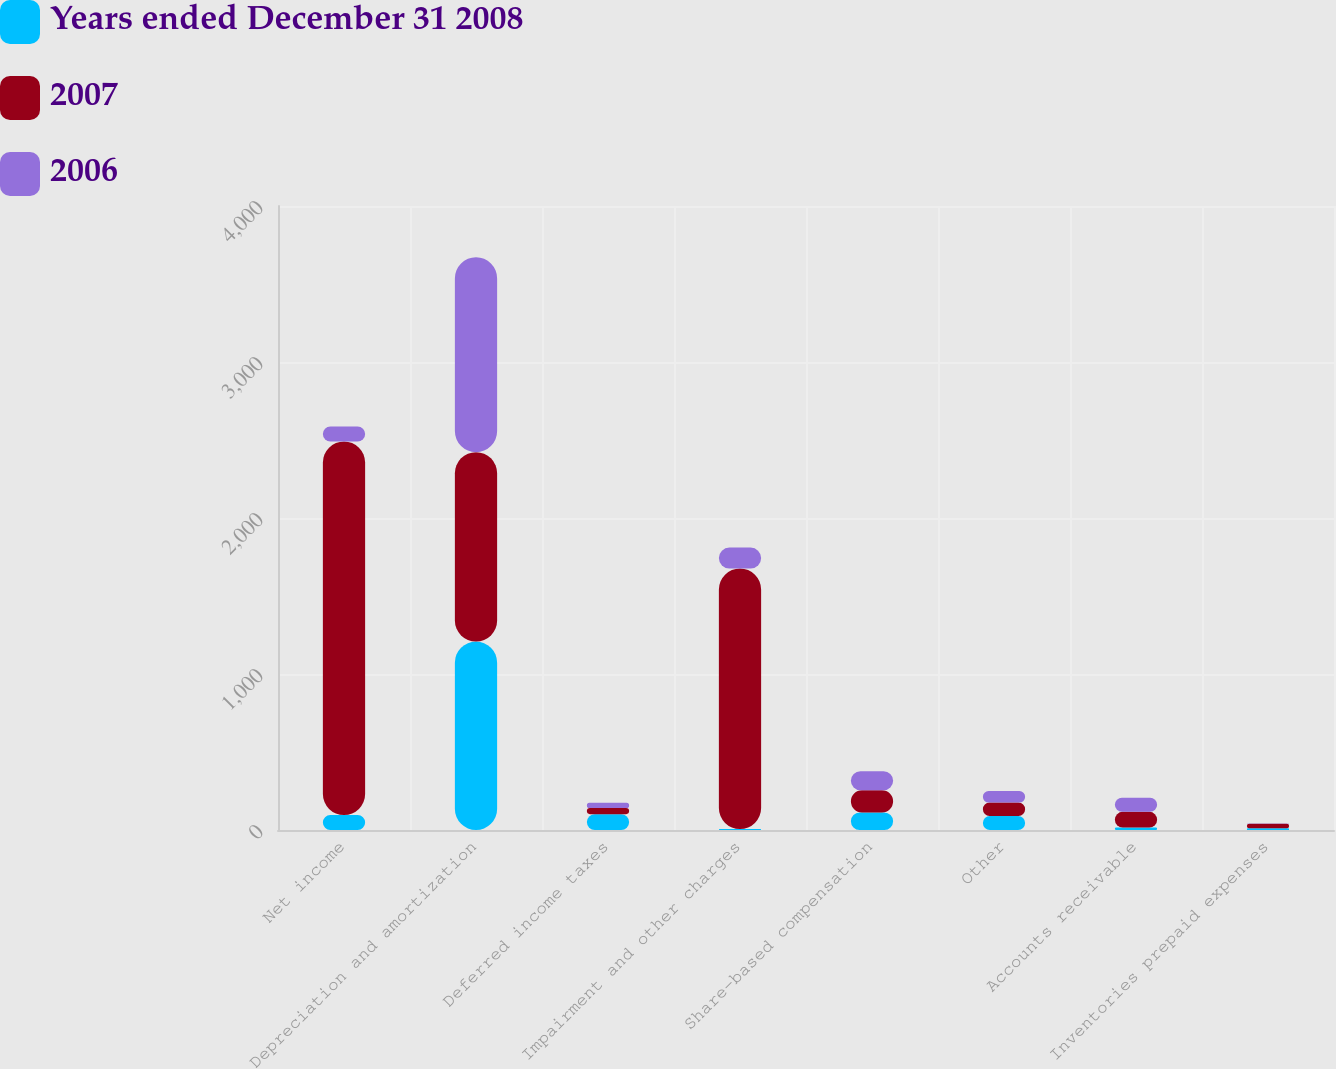Convert chart to OTSL. <chart><loc_0><loc_0><loc_500><loc_500><stacked_bar_chart><ecel><fcel>Net income<fcel>Depreciation and amortization<fcel>Deferred income taxes<fcel>Impairment and other charges<fcel>Share-based compensation<fcel>Other<fcel>Accounts receivable<fcel>Inventories prepaid expenses<nl><fcel>Years ended December 31 2008<fcel>95.5<fcel>1207.8<fcel>101.5<fcel>6<fcel>112.5<fcel>90.5<fcel>16.1<fcel>11<nl><fcel>2007<fcel>2395.1<fcel>1214.1<fcel>39.1<fcel>1670.3<fcel>142.4<fcel>85.3<fcel>100.2<fcel>29.6<nl><fcel>2006<fcel>95.5<fcel>1249.9<fcel>33.4<fcel>134.2<fcel>122.5<fcel>73.5<fcel>90.8<fcel>1.6<nl></chart> 